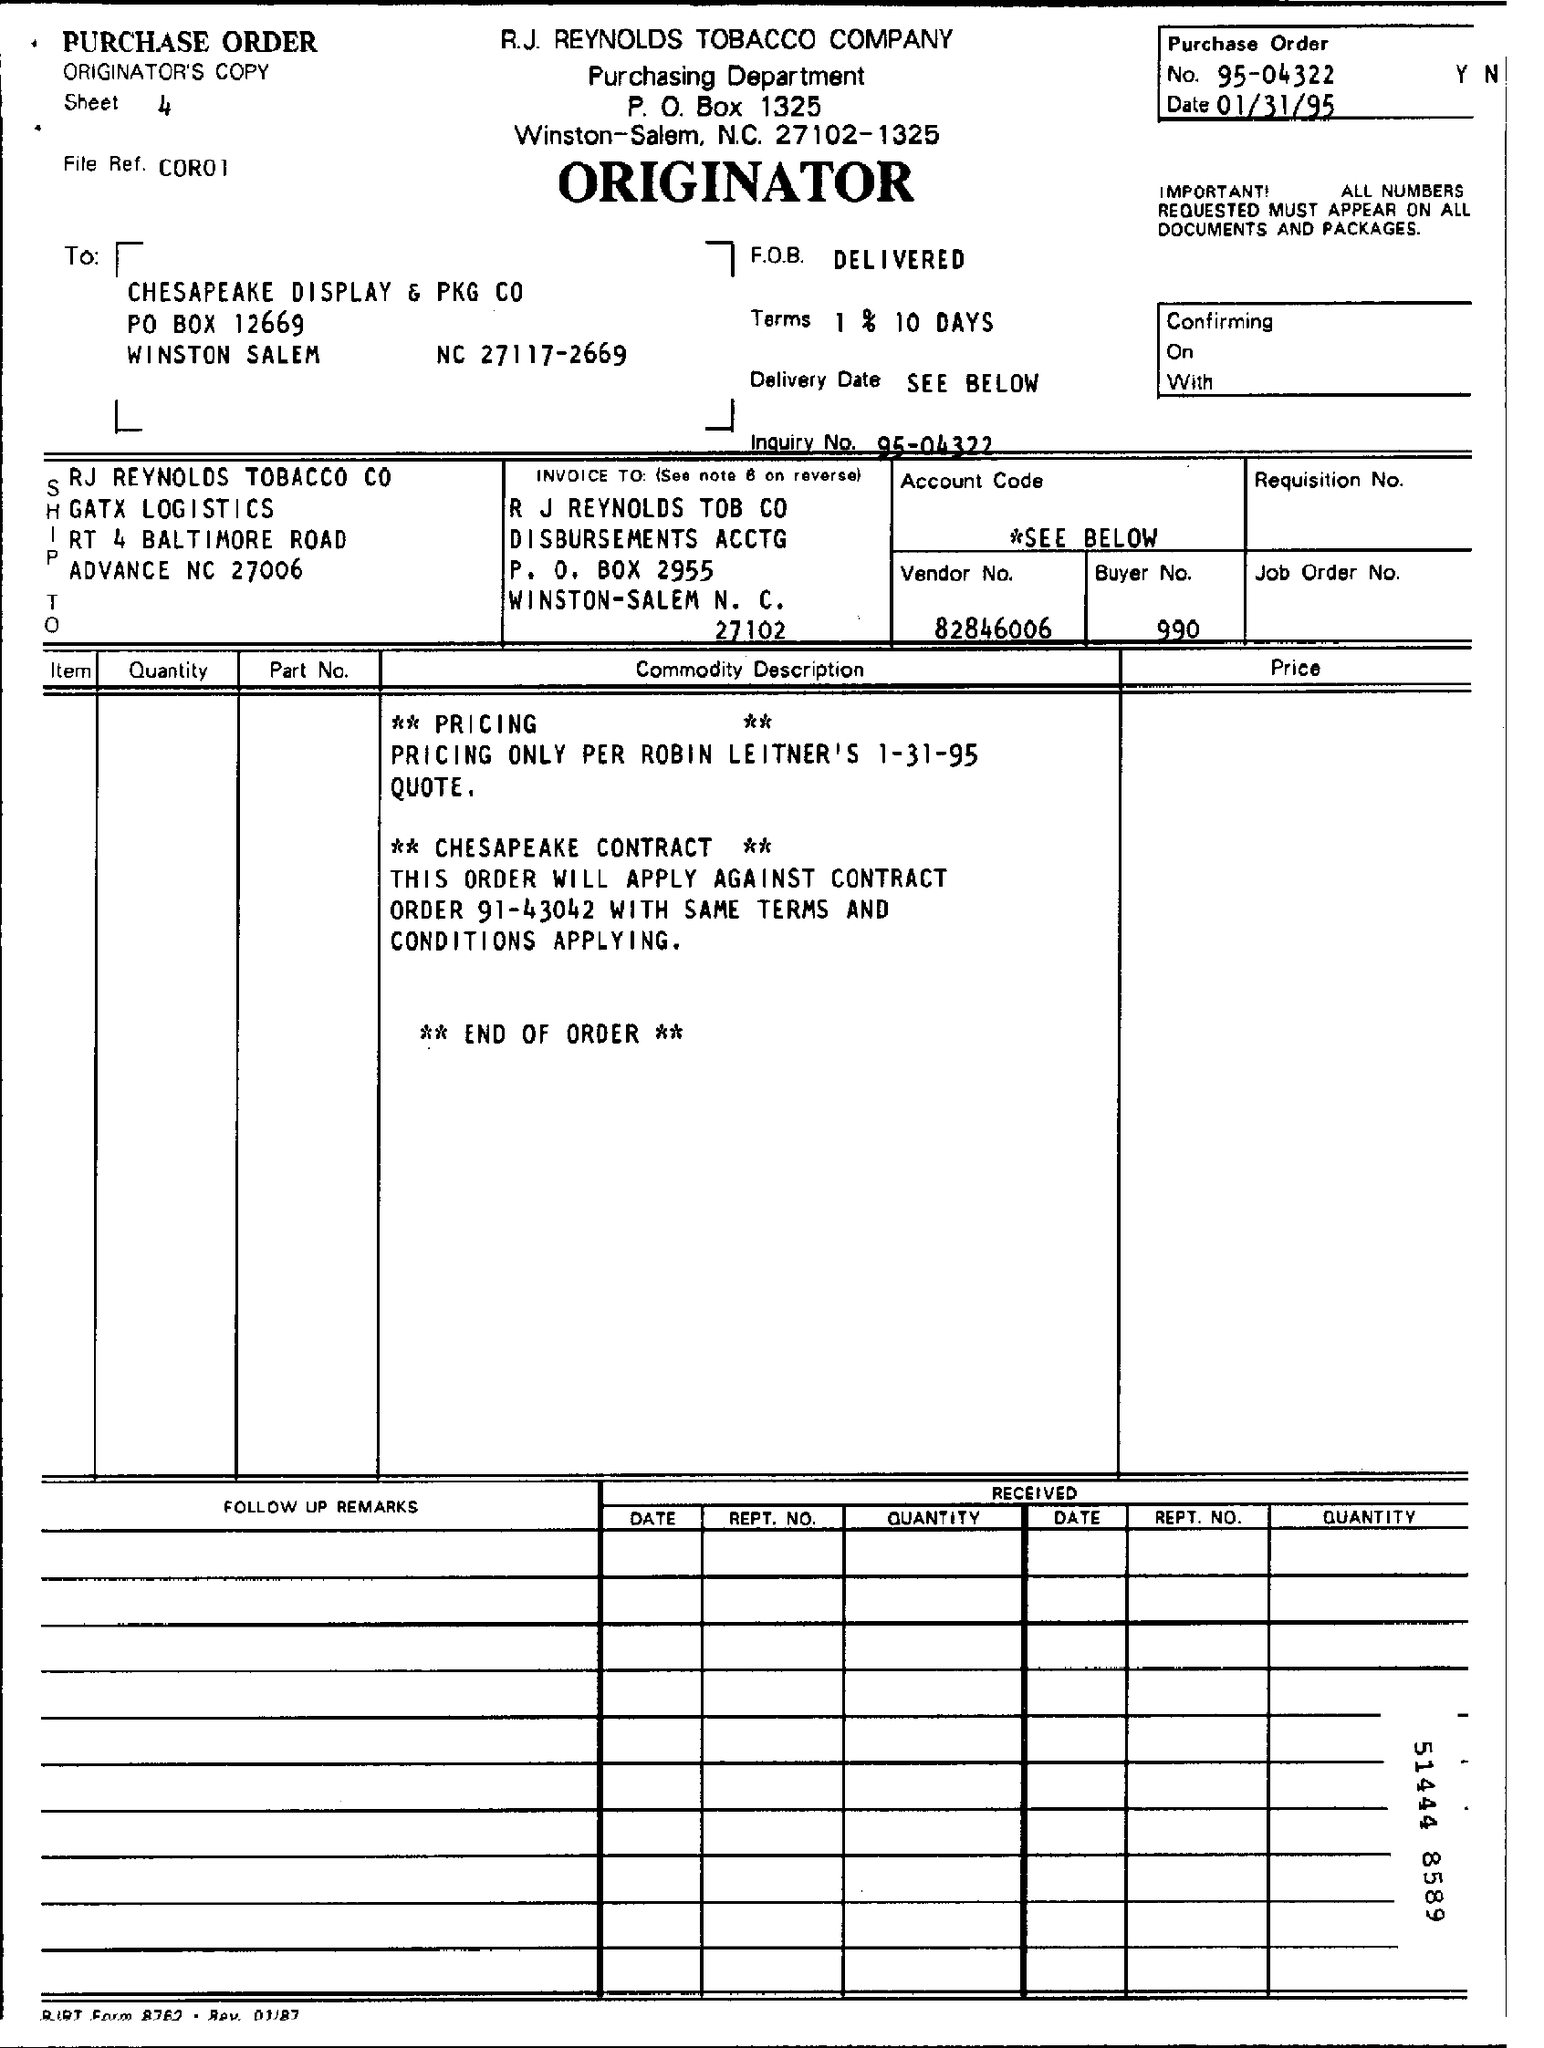Mention a couple of crucial points in this snapshot. The sentence "What type of this document? Purchase Order..." can be rewritten as:

"What is the document type? It is a Purchase Order. The buyer number is 990. The date mentioned at the top of the document is January 31, 1995. The Vendor Number is 82846006. The R.J. Reynolds Tobacco Company is the name of the company. 